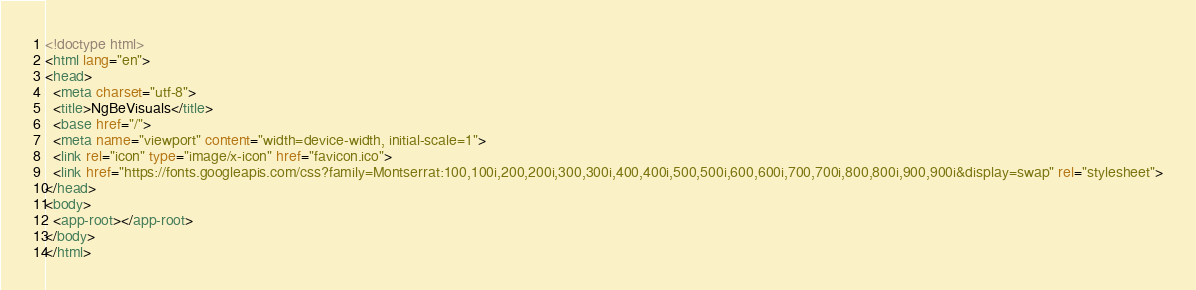Convert code to text. <code><loc_0><loc_0><loc_500><loc_500><_HTML_><!doctype html>
<html lang="en">
<head>
  <meta charset="utf-8">
  <title>NgBeVisuals</title>
  <base href="/">
  <meta name="viewport" content="width=device-width, initial-scale=1">
  <link rel="icon" type="image/x-icon" href="favicon.ico">
  <link href="https://fonts.googleapis.com/css?family=Montserrat:100,100i,200,200i,300,300i,400,400i,500,500i,600,600i,700,700i,800,800i,900,900i&display=swap" rel="stylesheet">
</head>
<body>
  <app-root></app-root>
</body>
</html>
</code> 